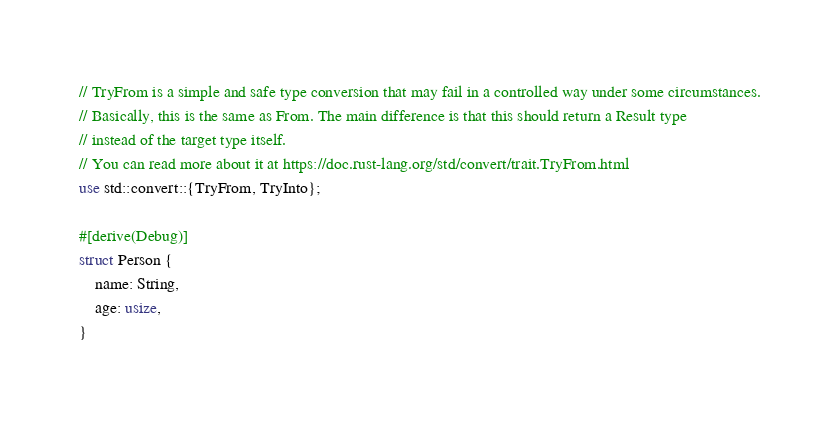<code> <loc_0><loc_0><loc_500><loc_500><_Rust_>// TryFrom is a simple and safe type conversion that may fail in a controlled way under some circumstances.
// Basically, this is the same as From. The main difference is that this should return a Result type
// instead of the target type itself.
// You can read more about it at https://doc.rust-lang.org/std/convert/trait.TryFrom.html
use std::convert::{TryFrom, TryInto};

#[derive(Debug)]
struct Person {
    name: String,
    age: usize,
}
</code> 